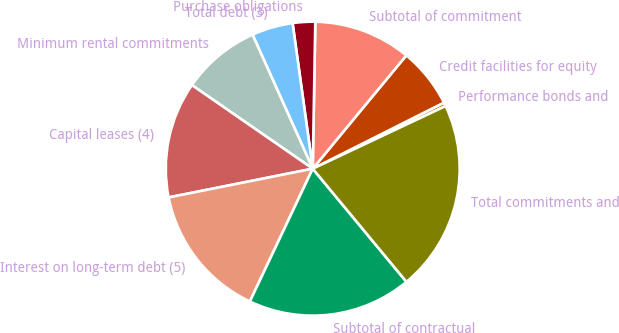<chart> <loc_0><loc_0><loc_500><loc_500><pie_chart><fcel>Performance bonds and<fcel>Credit facilities for equity<fcel>Subtotal of commitment<fcel>Purchase obligations<fcel>Total debt (3)<fcel>Minimum rental commitments<fcel>Capital leases (4)<fcel>Interest on long-term debt (5)<fcel>Subtotal of contractual<fcel>Total commitments and<nl><fcel>0.41%<fcel>6.59%<fcel>10.71%<fcel>2.47%<fcel>4.53%<fcel>8.65%<fcel>12.77%<fcel>14.83%<fcel>18.05%<fcel>21.01%<nl></chart> 